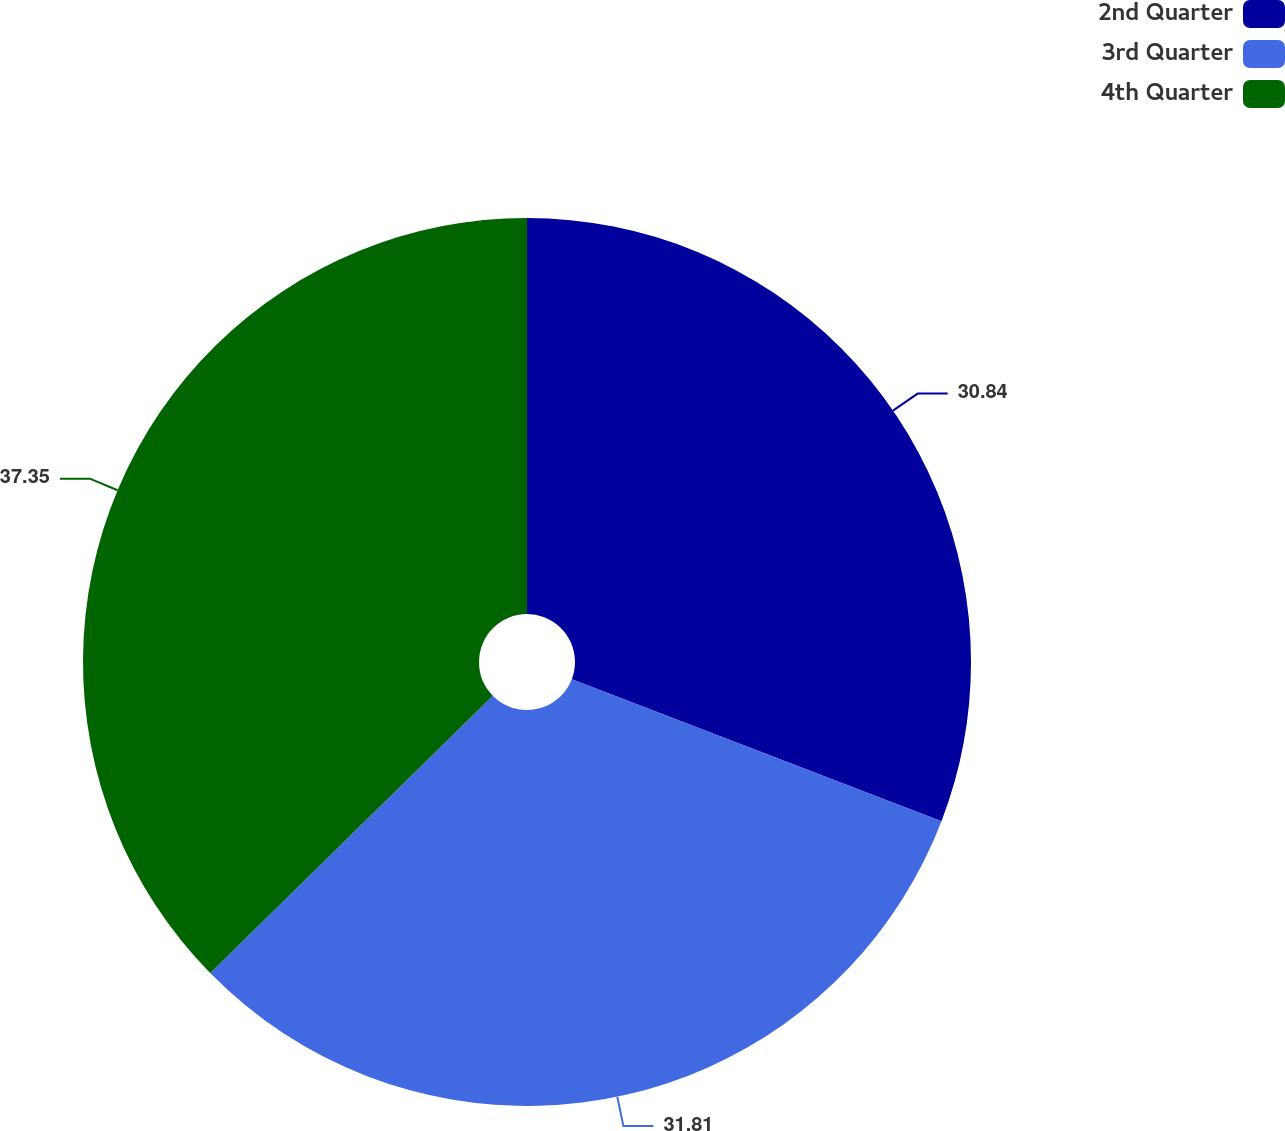<chart> <loc_0><loc_0><loc_500><loc_500><pie_chart><fcel>2nd Quarter<fcel>3rd Quarter<fcel>4th Quarter<nl><fcel>30.84%<fcel>31.81%<fcel>37.36%<nl></chart> 